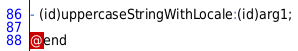Convert code to text. <code><loc_0><loc_0><loc_500><loc_500><_C_>- (id)uppercaseStringWithLocale:(id)arg1;

@end
</code> 